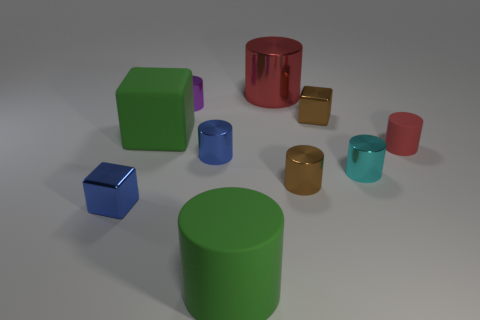The big green cube behind the matte object that is right of the big cylinder that is to the left of the large red object is made of what material?
Provide a succinct answer. Rubber. How many rubber objects are big red cubes or blue things?
Provide a succinct answer. 0. Is the large shiny thing the same color as the big cube?
Your response must be concise. No. Is there anything else that is made of the same material as the tiny purple thing?
Provide a short and direct response. Yes. What number of objects are tiny shiny cubes or red cylinders that are to the left of the tiny cyan object?
Your answer should be compact. 3. Do the thing that is on the right side of the cyan thing and the small brown metal block have the same size?
Keep it short and to the point. Yes. What number of other things are there of the same shape as the big red metallic thing?
Ensure brevity in your answer.  6. What number of brown things are big matte things or cylinders?
Your answer should be very brief. 1. There is a metal block left of the blue metal cylinder; is its color the same as the big metal thing?
Provide a succinct answer. No. What shape is the small purple thing that is made of the same material as the cyan cylinder?
Your answer should be compact. Cylinder. 